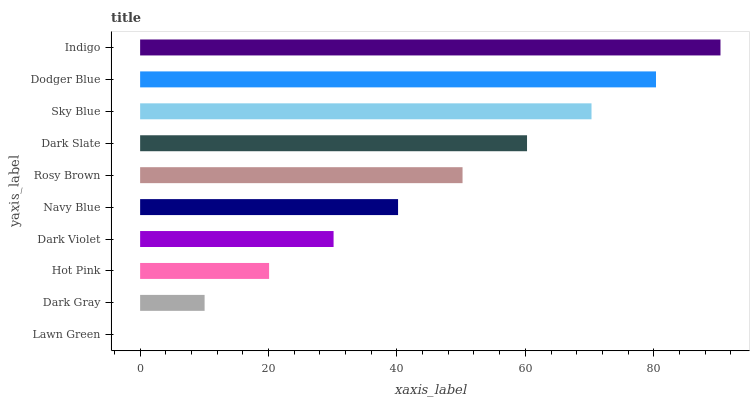Is Lawn Green the minimum?
Answer yes or no. Yes. Is Indigo the maximum?
Answer yes or no. Yes. Is Dark Gray the minimum?
Answer yes or no. No. Is Dark Gray the maximum?
Answer yes or no. No. Is Dark Gray greater than Lawn Green?
Answer yes or no. Yes. Is Lawn Green less than Dark Gray?
Answer yes or no. Yes. Is Lawn Green greater than Dark Gray?
Answer yes or no. No. Is Dark Gray less than Lawn Green?
Answer yes or no. No. Is Rosy Brown the high median?
Answer yes or no. Yes. Is Navy Blue the low median?
Answer yes or no. Yes. Is Lawn Green the high median?
Answer yes or no. No. Is Rosy Brown the low median?
Answer yes or no. No. 